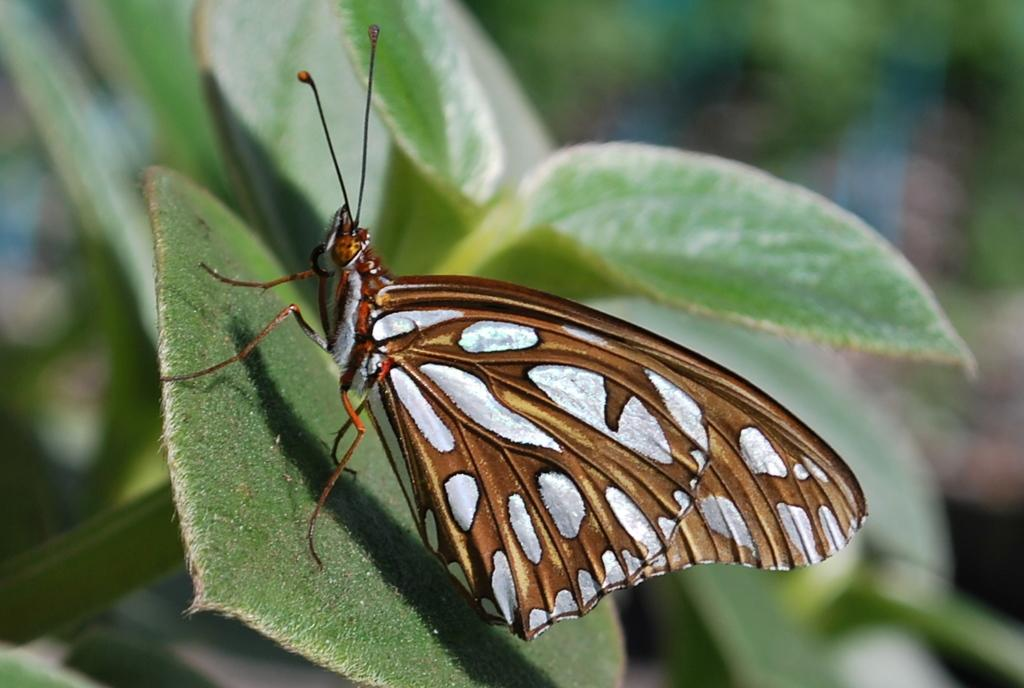What is the main subject of the image? There is a butterfly in the image. Where is the butterfly located? The butterfly is on a leaf. Can you describe the background of the image? The background of the image is blurred. What type of cannon is present in the image? There is no cannon present in the image; it features a butterfly on a leaf. Can you tell me how many hospitals are visible in the image? There are no hospitals visible in the image; it features a butterfly on a leaf. 